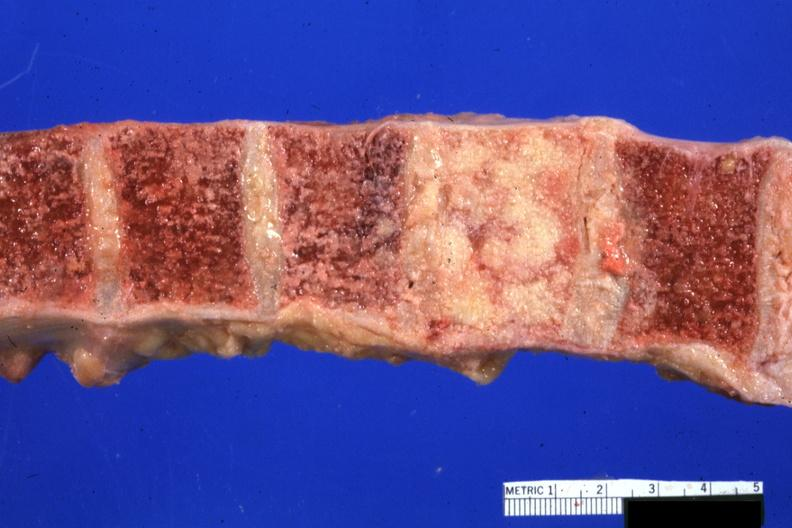s joints present?
Answer the question using a single word or phrase. Yes 